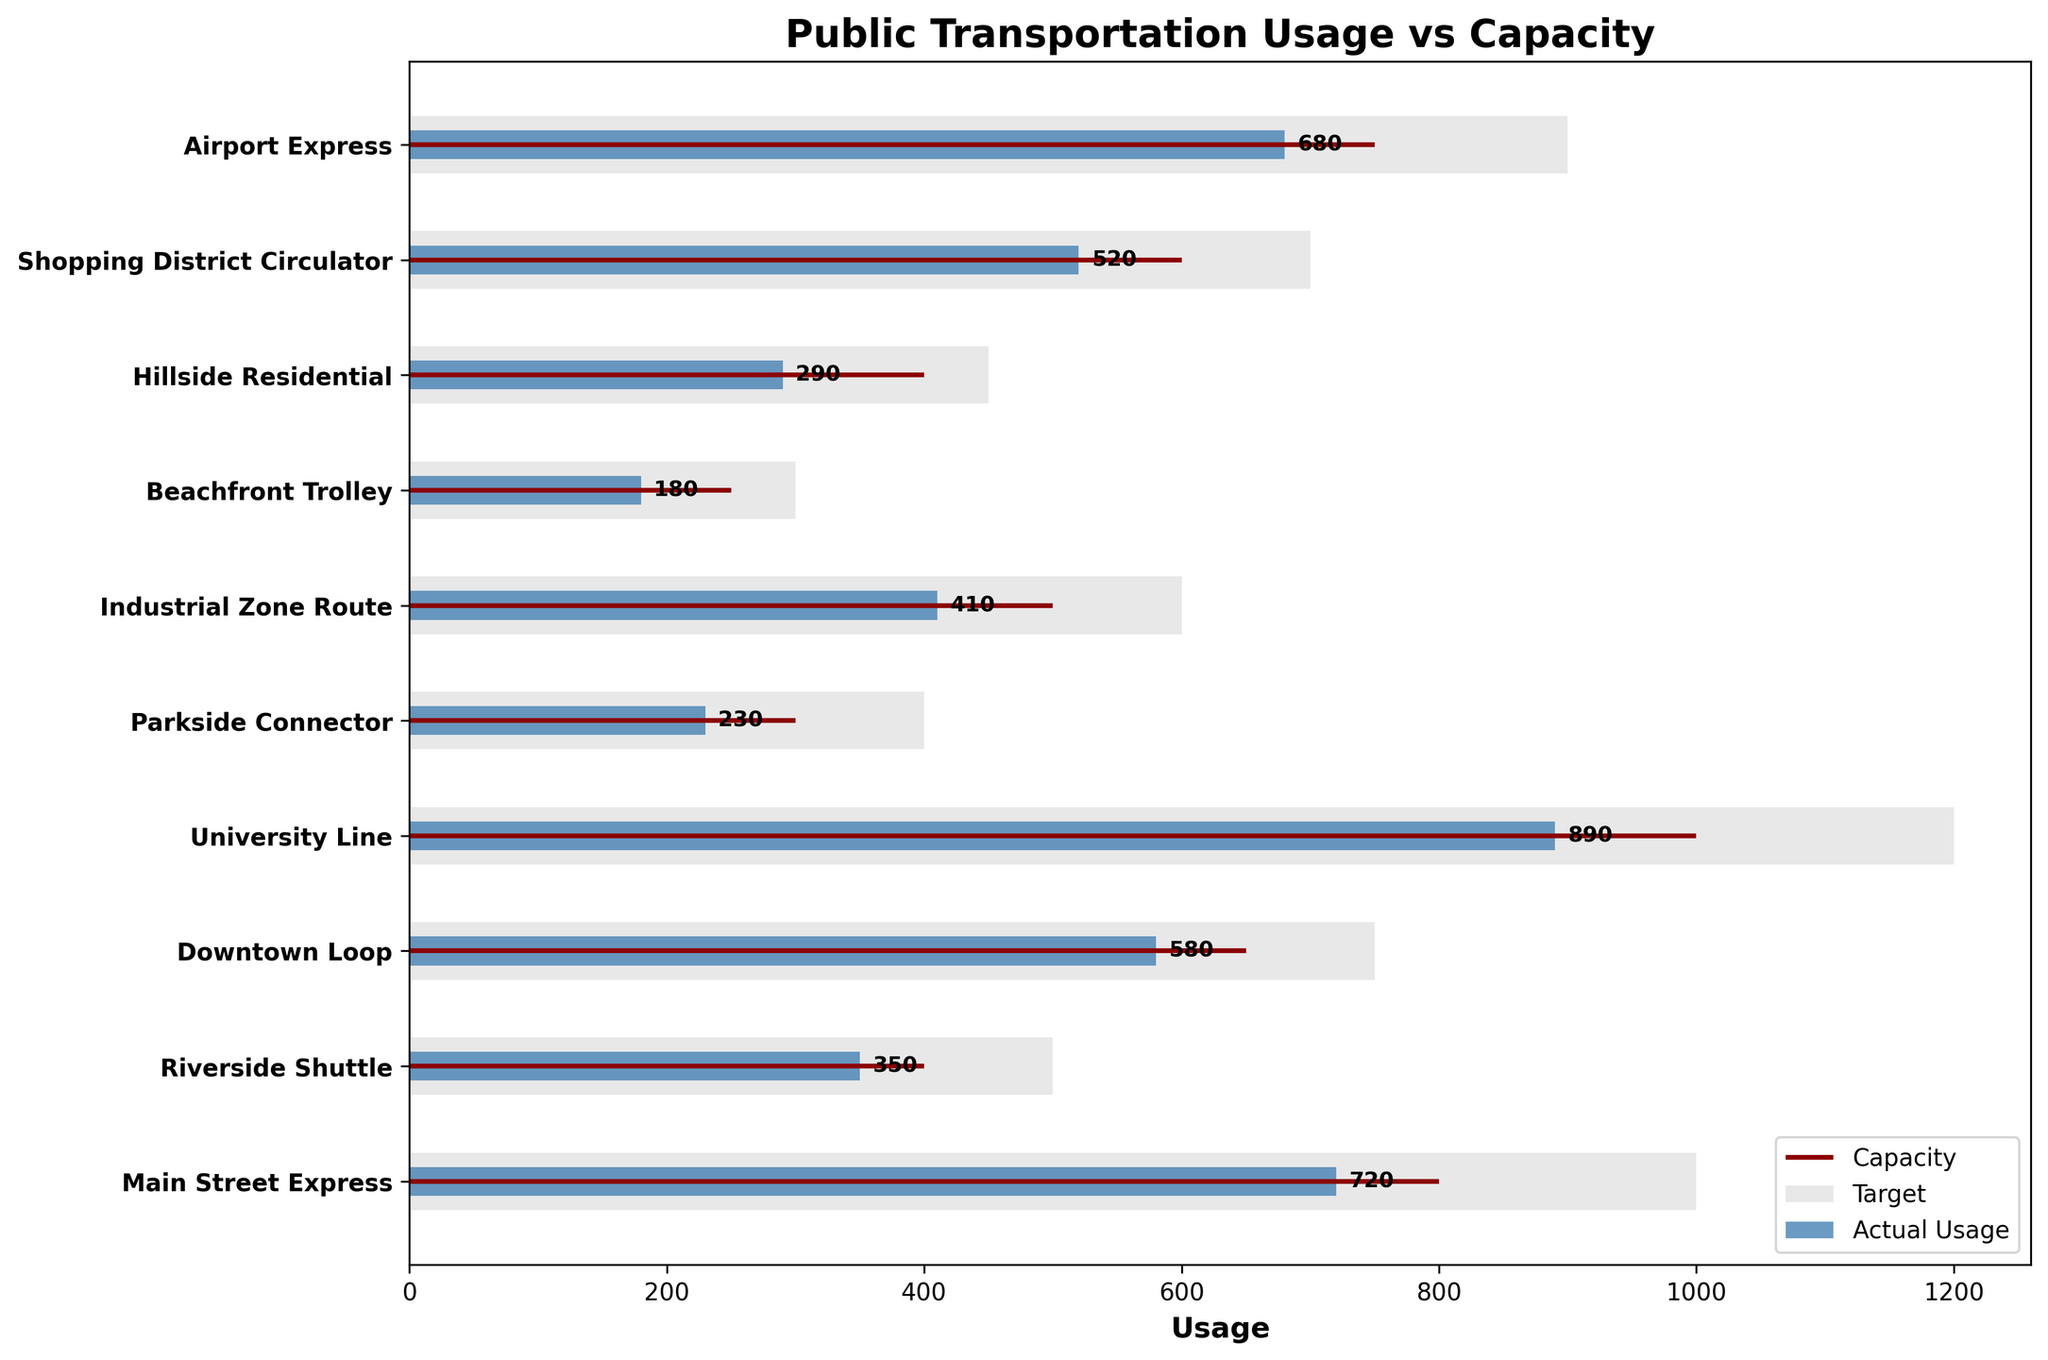What is the title of the chart? The title of the chart is typically displayed prominently at the top and summarizes what the chart is about.
Answer: Public Transportation Usage vs Capacity What color is used to represent the target usage? By examining the figure, it is clear the target usage is typically shown with a distinct color.
Answer: Dark red How many routes exceed their target usage? Identify bars where the actual usage exceeds the target usage for each route.
Answer: 2 Which route has the highest actual usage? Compare the actual usage bars and identify the tallest one.
Answer: University Line What is the difference in capacity between the Main Street Express and the Beachfront Trolley? Subtract the capacity of the Beachfront Trolley from the capacity of the Main Street Express (1000 - 300).
Answer: 700 Which route has the lowest actual usage? Compare the actual usage bars and identify the shortest one.
Answer: Beachfront Trolley How much greater is the capacity of the Airport Express than its actual usage? Subtract the actual usage from the capacity for the Airport Express (900 - 680).
Answer: 220 Which route is closest to reaching its target usage? Identify the route where the difference between actual usage and target usage is the smallest.
Answer: Riverside Shuttle What are the routes with actual usage less than their target usage? Identify routes where the actual usage bar does not reach the target line.
Answer: Riverside Shuttle, Downtown Loop, Parkside Connector, Industrial Zone Route, Beachfront Trolley, Hillside Residential, Shopping District Circulator, Airport Express How many routes have a capacity greater than 500? Count the number of routes with a capacity bar extending beyond the 500 mark.
Answer: 6 